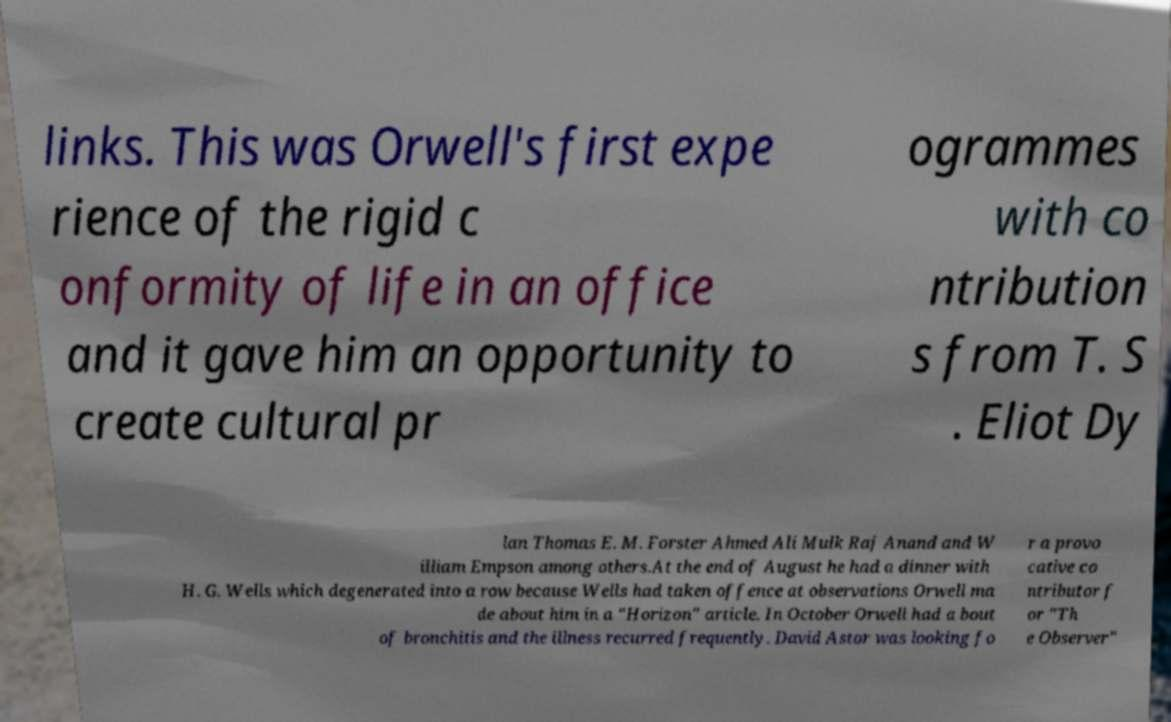Please identify and transcribe the text found in this image. links. This was Orwell's first expe rience of the rigid c onformity of life in an office and it gave him an opportunity to create cultural pr ogrammes with co ntribution s from T. S . Eliot Dy lan Thomas E. M. Forster Ahmed Ali Mulk Raj Anand and W illiam Empson among others.At the end of August he had a dinner with H. G. Wells which degenerated into a row because Wells had taken offence at observations Orwell ma de about him in a "Horizon" article. In October Orwell had a bout of bronchitis and the illness recurred frequently. David Astor was looking fo r a provo cative co ntributor f or "Th e Observer" 